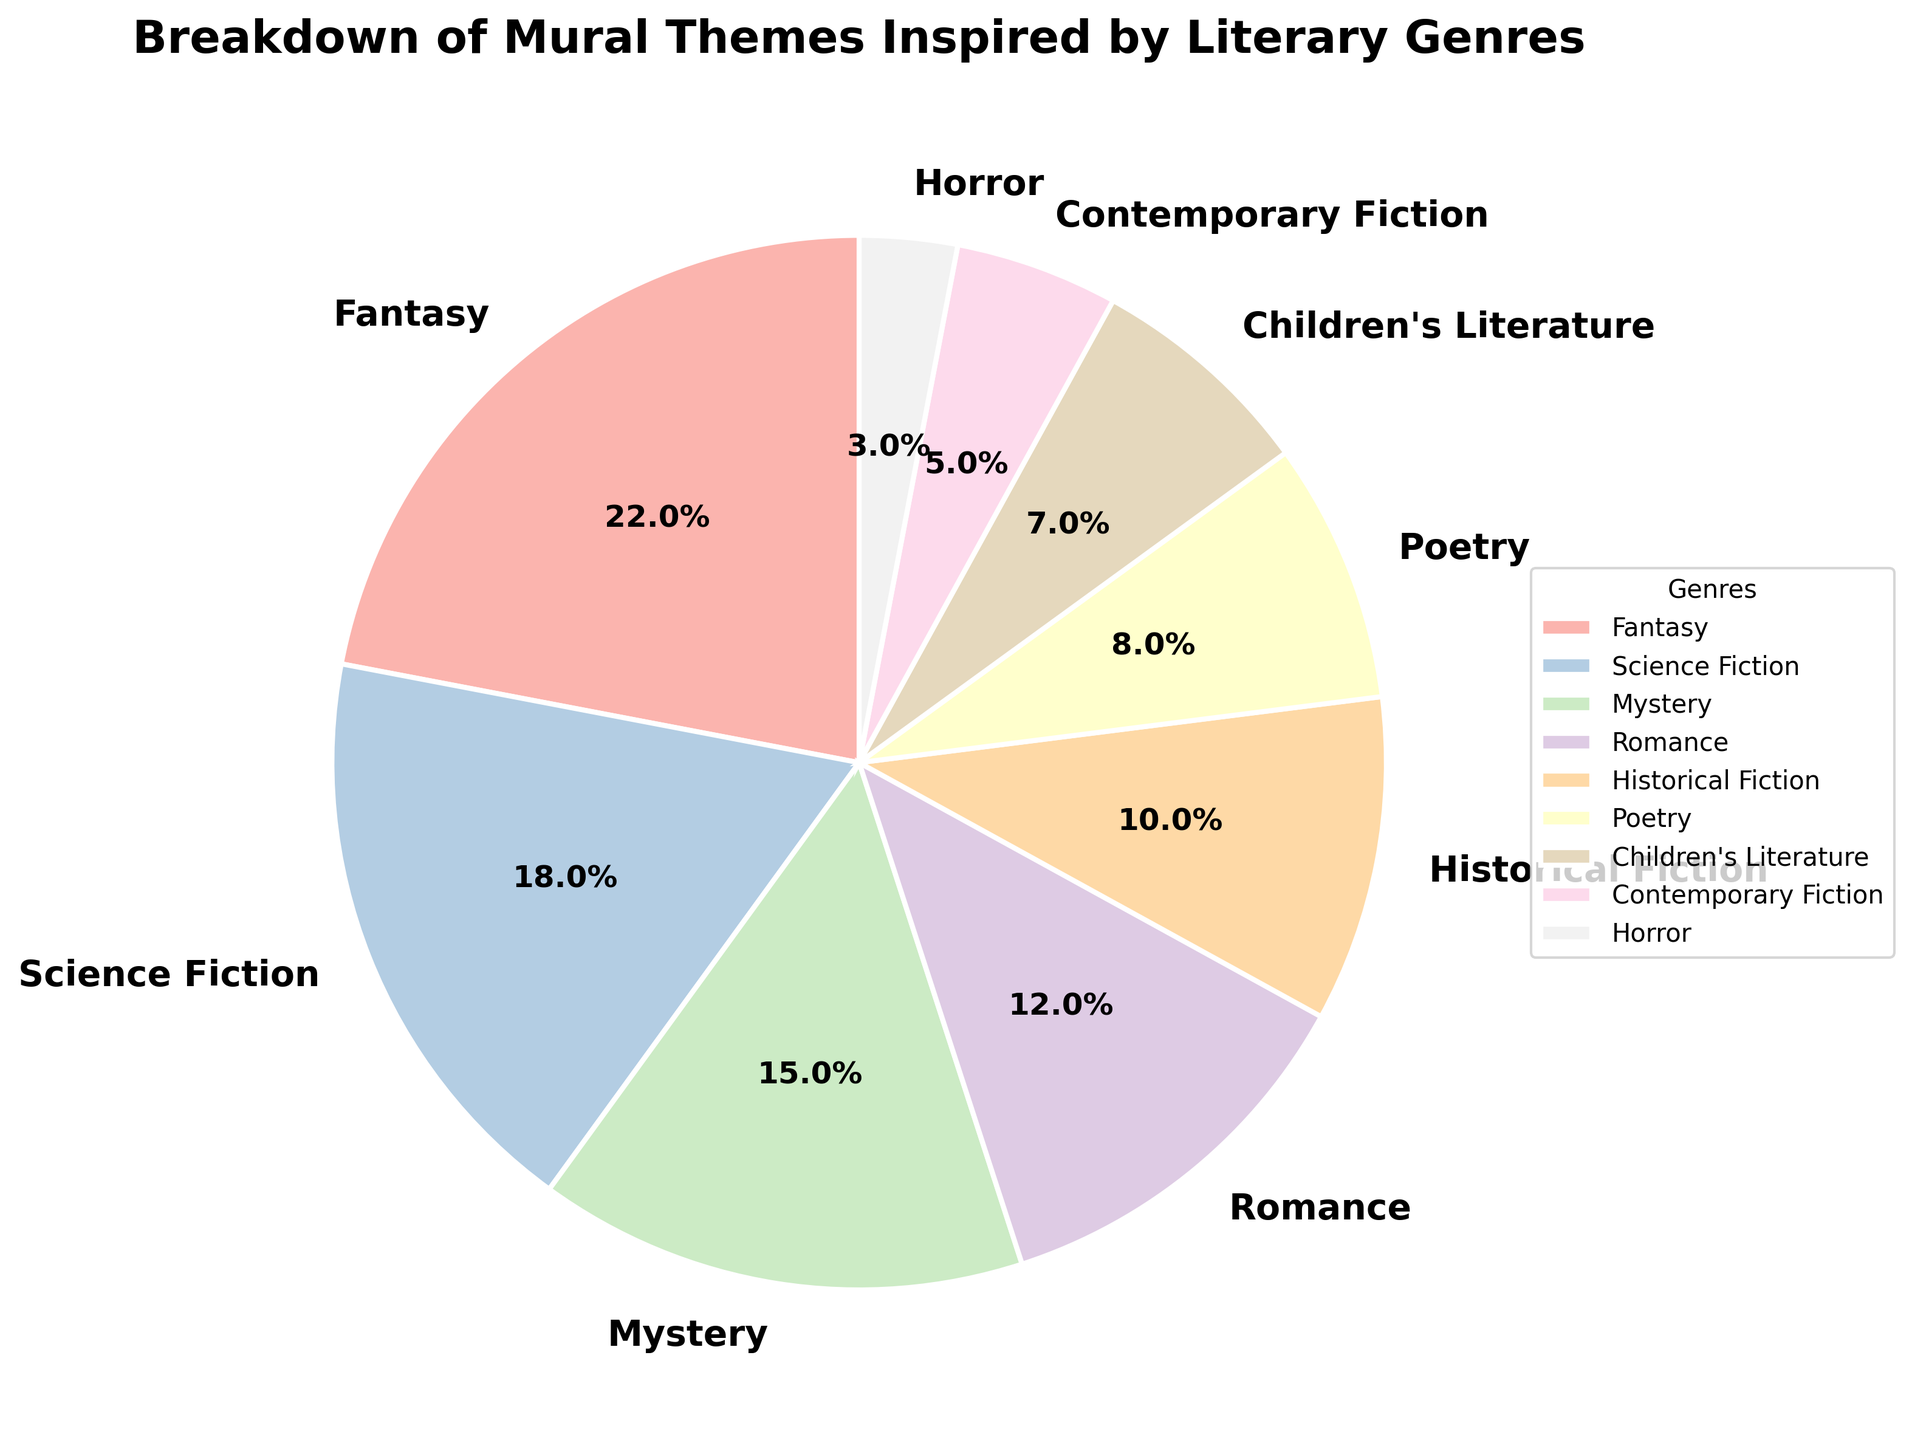Which genre has the largest percentage of mural themes? The pie chart shows the breakdown of the genres and their respective percentages. The slice labeled "Fantasy" has the largest percentage.
Answer: Fantasy Which two genres combined make up exactly 30% of the mural themes? By looking at the percentages given in the pie chart, we can find two genres that add up to 30%. Science Fiction (18%) and Poetry (8%) together add up to 26%, but Science Fiction (18%) and Romance (12%) together make 30%.
Answer: Science Fiction and Romance What is the difference in percentage between Children's Literature and Contemporary Fiction? Locate the slices labeled "Children's Literature" and "Contemporary Fiction." Children's Literature is 7% and Contemporary Fiction is 5%. Subtracting the percentages gives 7% - 5%.
Answer: 2% How many genres have a percentage lower than 10%? Identify the slices with percentages below 10%. Historical Fiction (10%), Poetry (8%), Children's Literature (7%), Contemporary Fiction (5%), and Horror (3%) meet this criterion. This gives a count of 5.
Answer: 5 Is the percentage of Horror themes greater than, less than, or equal to the combined percentage of Poetry and Children's Literature themes? Find the percentages: Horror is 3%, Poetry is 8%, and Children's Literature is 7%. Adding Poetry and Children's Literature gives 8% + 7% = 15%. Compare this with the Horror percentage.
Answer: Less than Compare the combined percentages of Mystery and Romance themes to that of Fantasy themes. Which is larger? Find the percentages of each genre: Mystery is 15%, Romance is 12%, and Fantasy is 22%. Adding Mystery and Romance gives 15% + 12% = 27%. Compare this with the 22% of Fantasy.
Answer: Mystery and Romance themes What visual attribute distinguishes Historical Fiction from Children's Literature on the pie chart? Look at the visual differences between the slices labeled "Historical Fiction" and "Children's Literature." One difference is the relative size of the slices shown in the pie chart.
Answer: Slice size If you combined the top three genres, what percentage of the mural themes would that represent? The top three genres by percentage are Fantasy (22%), Science Fiction (18%), and Mystery (15%). Adding these together gives 22% + 18% + 15% = 55%.
Answer: 55% Which is the smallest genre, and what is its percentage? Identify the smallest slice on the pie chart and read its label. The smallest genre is Horror, which is labeled as 3%.
Answer: Horror, 3% Is the percentage of Science Fiction themes closer to that of Mystery or Romance themes? Find the percentages: Science Fiction is 18%, Mystery is 15%, and Romance is 12%. Calculate the differences:
Answer: Closer to Mystery 